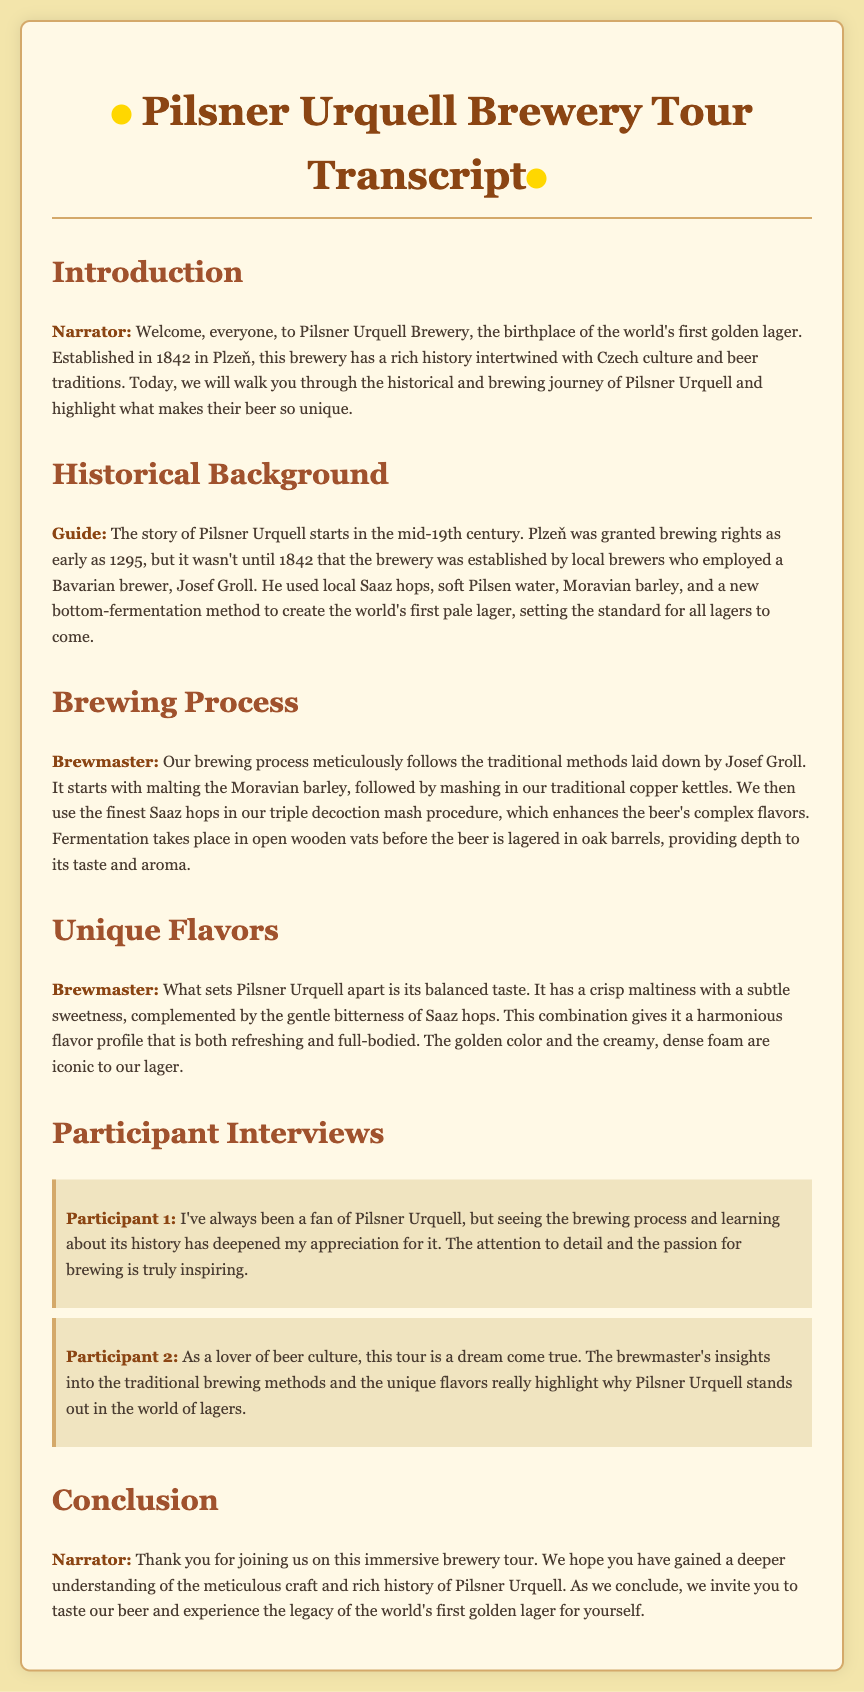What year was Pilsner Urquell Brewery established? The document states that Pilsner Urquell Brewery was established in 1842.
Answer: 1842 Who is the Bavarian brewer mentioned in the document? The document mentions Josef Groll as the Bavarian brewer employed to create the lager.
Answer: Josef Groll What method did Josef Groll use to create the lager? The brewing method used was bottom-fermentation, as stated in the historical background section.
Answer: Bottom-fermentation What main ingredients are used in Pilsner Urquell beer? The guide mentions local Saaz hops, soft Pilsen water, and Moravian barley as main ingredients.
Answer: Saaz hops, Pilsen water, Moravian barley How is the fermentation process conducted? The brewmaster explains that fermentation takes place in open wooden vats.
Answer: Open wooden vats What unique flavor profile is highlighted for Pilsner Urquell? The brewmaster describes the beer's balanced taste with crisp maltiness and gentle bitterness.
Answer: Crisp maltiness and gentle bitterness Which aspect of the brewery tour impressed Participant 1 the most? Participant 1 expressed that the attention to detail and passion for brewing inspired him.
Answer: Attention to detail and passion for brewing What did Participant 2 find exciting about the tour? Participant 2 found the insights into traditional brewing methods and unique flavors exciting.
Answer: Insights into traditional brewing methods and unique flavors 